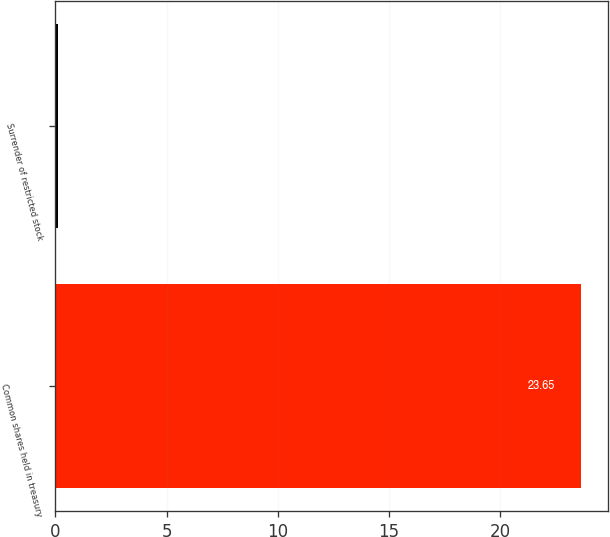Convert chart. <chart><loc_0><loc_0><loc_500><loc_500><bar_chart><fcel>Common shares held in treasury<fcel>Surrender of restricted stock<nl><fcel>23.65<fcel>0.1<nl></chart> 